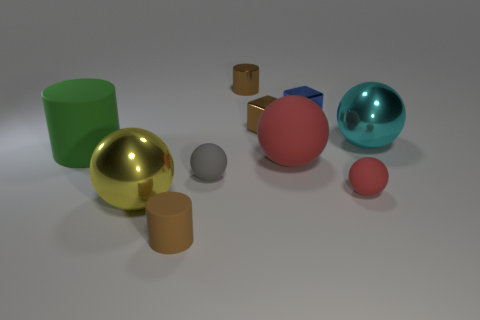There is a brown cylinder to the right of the brown object in front of the big green cylinder; is there a cyan sphere behind it?
Your response must be concise. No. Is the color of the shiny block that is on the left side of the small blue shiny thing the same as the big shiny thing behind the big green matte cylinder?
Offer a very short reply. No. What material is the cylinder that is the same size as the yellow sphere?
Ensure brevity in your answer.  Rubber. What is the size of the shiny sphere right of the brown cylinder behind the rubber cylinder behind the tiny gray matte ball?
Give a very brief answer. Large. There is a matte cylinder that is on the right side of the big matte cylinder; what size is it?
Make the answer very short. Small. How many shiny things are to the right of the big red thing and behind the cyan metal thing?
Offer a terse response. 1. What material is the cylinder that is behind the metal sphere that is to the right of the tiny blue cube?
Provide a short and direct response. Metal. There is a gray thing that is the same shape as the large red object; what is it made of?
Keep it short and to the point. Rubber. Is there a gray rubber cylinder?
Give a very brief answer. No. There is a large object that is the same material as the large yellow ball; what is its shape?
Your response must be concise. Sphere. 